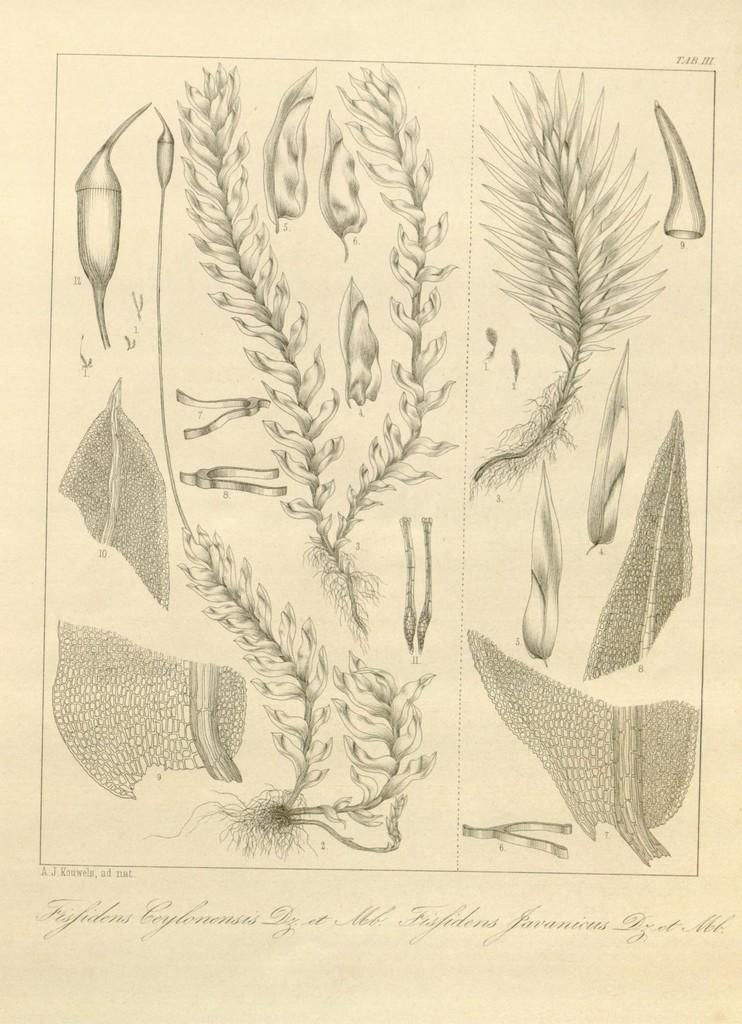Could you give a brief overview of what you see in this image? This image consists of a paper. In which there are pictures. It looks like plants and trees. At the bottom, there is a text. 